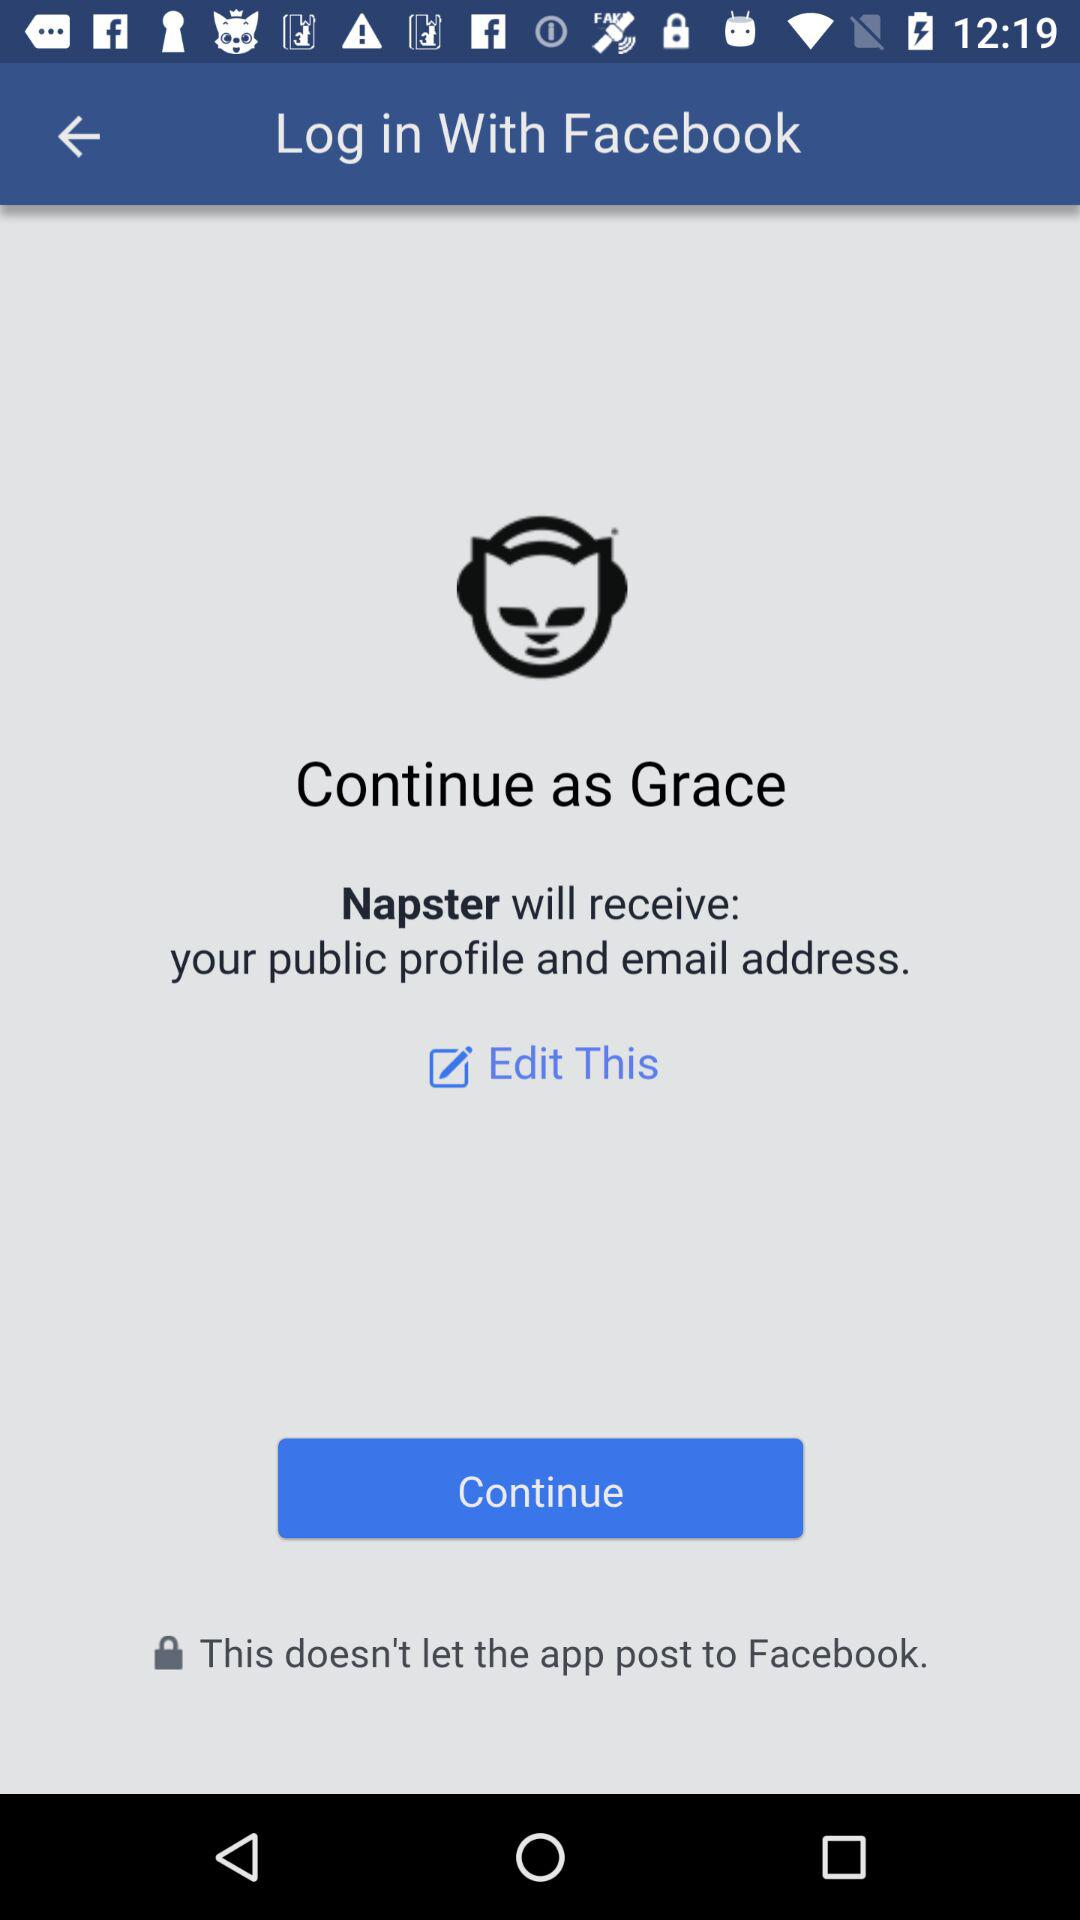What is the user name? The user name is Grace. 